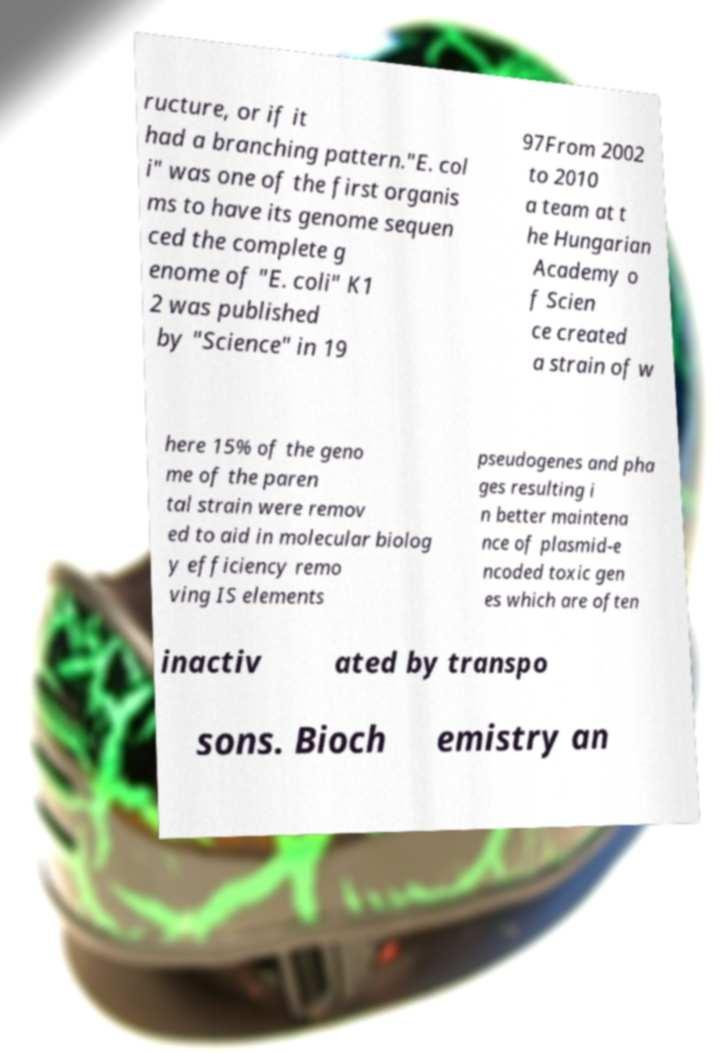There's text embedded in this image that I need extracted. Can you transcribe it verbatim? ructure, or if it had a branching pattern."E. col i" was one of the first organis ms to have its genome sequen ced the complete g enome of "E. coli" K1 2 was published by "Science" in 19 97From 2002 to 2010 a team at t he Hungarian Academy o f Scien ce created a strain of w here 15% of the geno me of the paren tal strain were remov ed to aid in molecular biolog y efficiency remo ving IS elements pseudogenes and pha ges resulting i n better maintena nce of plasmid-e ncoded toxic gen es which are often inactiv ated by transpo sons. Bioch emistry an 